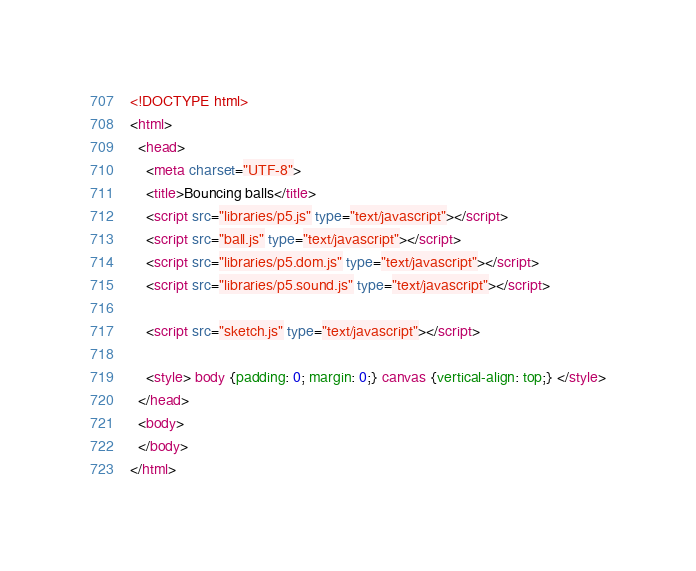<code> <loc_0><loc_0><loc_500><loc_500><_HTML_><!DOCTYPE html>
<html>
  <head>
    <meta charset="UTF-8">
    <title>Bouncing balls</title>
    <script src="libraries/p5.js" type="text/javascript"></script>
    <script src="ball.js" type="text/javascript"></script>
    <script src="libraries/p5.dom.js" type="text/javascript"></script>
    <script src="libraries/p5.sound.js" type="text/javascript"></script>

    <script src="sketch.js" type="text/javascript"></script>

    <style> body {padding: 0; margin: 0;} canvas {vertical-align: top;} </style>
  </head>
  <body>
  </body>
</html>
</code> 